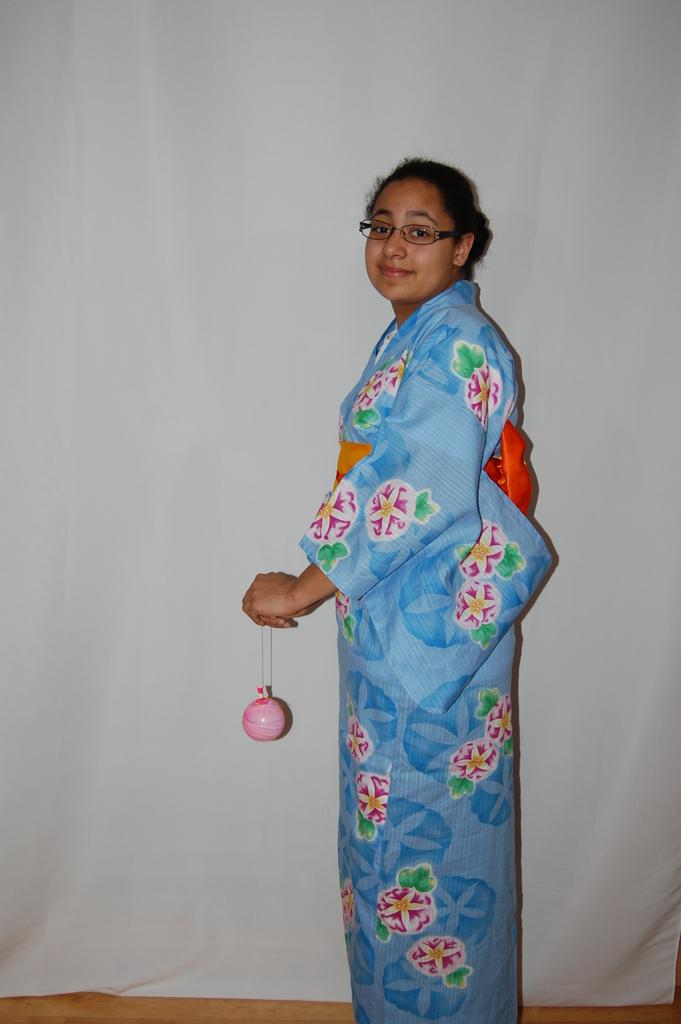What can be seen in the image? There is a person in the image. What is the person holding? The person is holding an object. What is the person wearing? The person is wearing a blue dress. What is the color of the background in the image? The background of the image is white. What type of behavior does the doll exhibit in the image? There is no doll present in the image, so it is not possible to answer that question. 